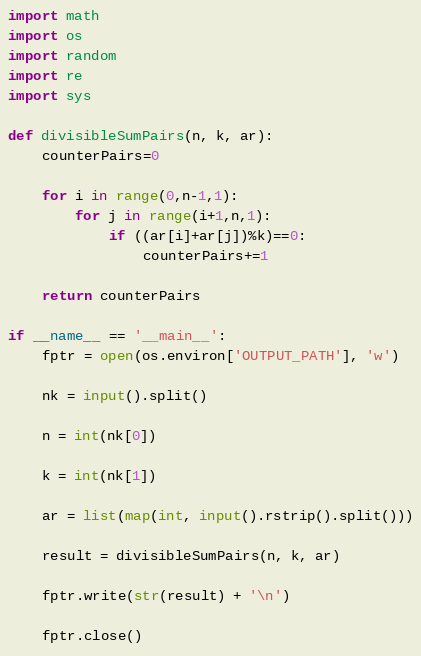<code> <loc_0><loc_0><loc_500><loc_500><_Python_>import math
import os
import random
import re
import sys

def divisibleSumPairs(n, k, ar):
    counterPairs=0

    for i in range(0,n-1,1):
        for j in range(i+1,n,1):
            if ((ar[i]+ar[j])%k)==0:
                counterPairs+=1
                
    return counterPairs

if __name__ == '__main__':
    fptr = open(os.environ['OUTPUT_PATH'], 'w')

    nk = input().split()

    n = int(nk[0])

    k = int(nk[1])

    ar = list(map(int, input().rstrip().split()))

    result = divisibleSumPairs(n, k, ar)

    fptr.write(str(result) + '\n')

    fptr.close()
</code> 